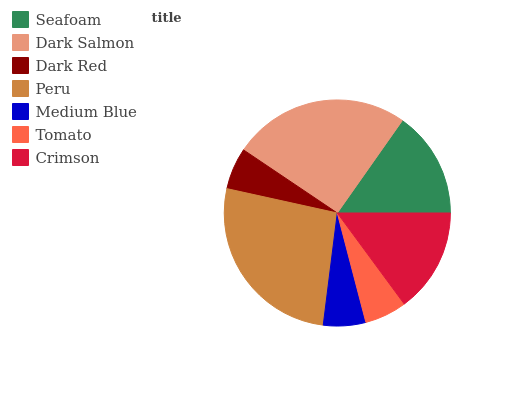Is Dark Red the minimum?
Answer yes or no. Yes. Is Peru the maximum?
Answer yes or no. Yes. Is Dark Salmon the minimum?
Answer yes or no. No. Is Dark Salmon the maximum?
Answer yes or no. No. Is Dark Salmon greater than Seafoam?
Answer yes or no. Yes. Is Seafoam less than Dark Salmon?
Answer yes or no. Yes. Is Seafoam greater than Dark Salmon?
Answer yes or no. No. Is Dark Salmon less than Seafoam?
Answer yes or no. No. Is Crimson the high median?
Answer yes or no. Yes. Is Crimson the low median?
Answer yes or no. Yes. Is Tomato the high median?
Answer yes or no. No. Is Dark Salmon the low median?
Answer yes or no. No. 